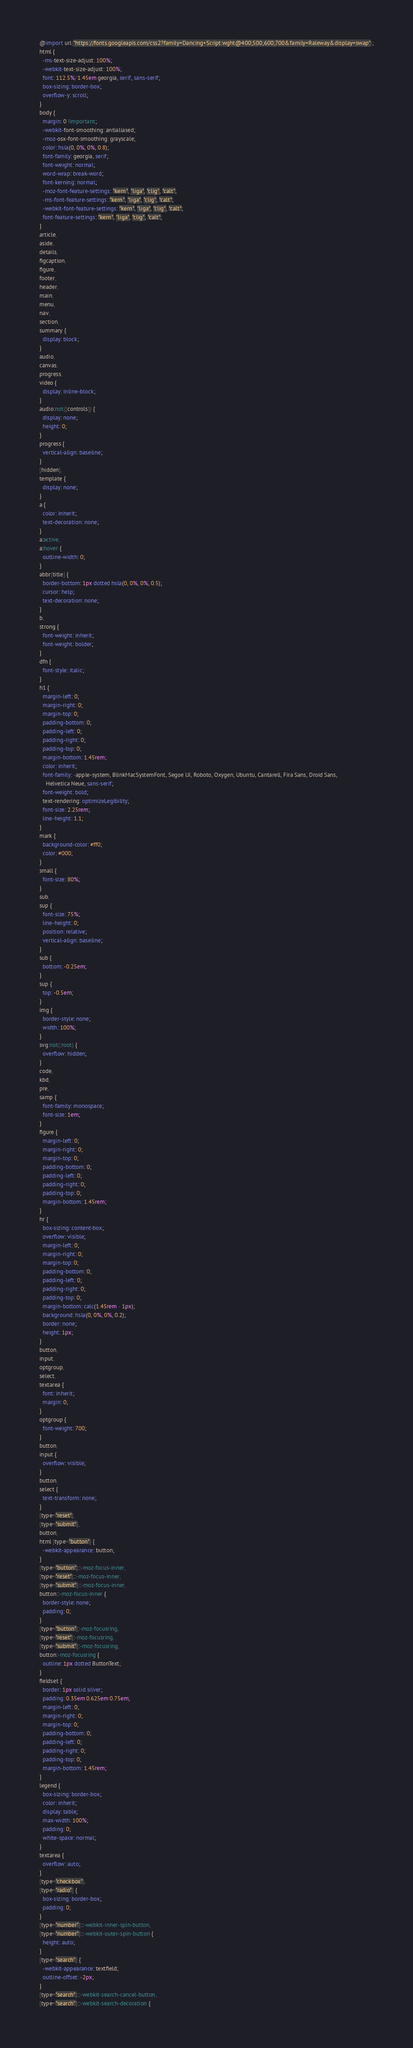<code> <loc_0><loc_0><loc_500><loc_500><_CSS_>@import url("https://fonts.googleapis.com/css2?family=Dancing+Script:wght@400;500;600;700&family=Raleway&display=swap");
html {
  -ms-text-size-adjust: 100%;
  -webkit-text-size-adjust: 100%;
  font: 112.5%/1.45em georgia, serif, sans-serif;
  box-sizing: border-box;
  overflow-y: scroll;
}
body {
  margin: 0 !important;
  -webkit-font-smoothing: antialiased;
  -moz-osx-font-smoothing: grayscale;
  color: hsla(0, 0%, 0%, 0.8);
  font-family: georgia, serif;
  font-weight: normal;
  word-wrap: break-word;
  font-kerning: normal;
  -moz-font-feature-settings: "kern", "liga", "clig", "calt";
  -ms-font-feature-settings: "kern", "liga", "clig", "calt";
  -webkit-font-feature-settings: "kern", "liga", "clig", "calt";
  font-feature-settings: "kern", "liga", "clig", "calt";
}
article,
aside,
details,
figcaption,
figure,
footer,
header,
main,
menu,
nav,
section,
summary {
  display: block;
}
audio,
canvas,
progress,
video {
  display: inline-block;
}
audio:not([controls]) {
  display: none;
  height: 0;
}
progress {
  vertical-align: baseline;
}
[hidden],
template {
  display: none;
}
a {
  color: inherit;
  text-decoration: none;
}
a:active,
a:hover {
  outline-width: 0;
}
abbr[title] {
  border-bottom: 1px dotted hsla(0, 0%, 0%, 0.5);
  cursor: help;
  text-decoration: none;
}
b,
strong {
  font-weight: inherit;
  font-weight: bolder;
}
dfn {
  font-style: italic;
}
h1 {
  margin-left: 0;
  margin-right: 0;
  margin-top: 0;
  padding-bottom: 0;
  padding-left: 0;
  padding-right: 0;
  padding-top: 0;
  margin-bottom: 1.45rem;
  color: inherit;
  font-family: -apple-system, BlinkMacSystemFont, Segoe UI, Roboto, Oxygen, Ubuntu, Cantarell, Fira Sans, Droid Sans,
    Helvetica Neue, sans-serif;
  font-weight: bold;
  text-rendering: optimizeLegibility;
  font-size: 2.25rem;
  line-height: 1.1;
}
mark {
  background-color: #ff0;
  color: #000;
}
small {
  font-size: 80%;
}
sub,
sup {
  font-size: 75%;
  line-height: 0;
  position: relative;
  vertical-align: baseline;
}
sub {
  bottom: -0.25em;
}
sup {
  top: -0.5em;
}
img {
  border-style: none;
  width: 100%;
}
svg:not(:root) {
  overflow: hidden;
}
code,
kbd,
pre,
samp {
  font-family: monospace;
  font-size: 1em;
}
figure {
  margin-left: 0;
  margin-right: 0;
  margin-top: 0;
  padding-bottom: 0;
  padding-left: 0;
  padding-right: 0;
  padding-top: 0;
  margin-bottom: 1.45rem;
}
hr {
  box-sizing: content-box;
  overflow: visible;
  margin-left: 0;
  margin-right: 0;
  margin-top: 0;
  padding-bottom: 0;
  padding-left: 0;
  padding-right: 0;
  padding-top: 0;
  margin-bottom: calc(1.45rem - 1px);
  background: hsla(0, 0%, 0%, 0.2);
  border: none;
  height: 1px;
}
button,
input,
optgroup,
select,
textarea {
  font: inherit;
  margin: 0;
}
optgroup {
  font-weight: 700;
}
button,
input {
  overflow: visible;
}
button,
select {
  text-transform: none;
}
[type="reset"],
[type="submit"],
button,
html [type="button"] {
  -webkit-appearance: button;
}
[type="button"]::-moz-focus-inner,
[type="reset"]::-moz-focus-inner,
[type="submit"]::-moz-focus-inner,
button::-moz-focus-inner {
  border-style: none;
  padding: 0;
}
[type="button"]:-moz-focusring,
[type="reset"]:-moz-focusring,
[type="submit"]:-moz-focusring,
button:-moz-focusring {
  outline: 1px dotted ButtonText;
}
fieldset {
  border: 1px solid silver;
  padding: 0.35em 0.625em 0.75em;
  margin-left: 0;
  margin-right: 0;
  margin-top: 0;
  padding-bottom: 0;
  padding-left: 0;
  padding-right: 0;
  padding-top: 0;
  margin-bottom: 1.45rem;
}
legend {
  box-sizing: border-box;
  color: inherit;
  display: table;
  max-width: 100%;
  padding: 0;
  white-space: normal;
}
textarea {
  overflow: auto;
}
[type="checkbox"],
[type="radio"] {
  box-sizing: border-box;
  padding: 0;
}
[type="number"]::-webkit-inner-spin-button,
[type="number"]::-webkit-outer-spin-button {
  height: auto;
}
[type="search"] {
  -webkit-appearance: textfield;
  outline-offset: -2px;
}
[type="search"]::-webkit-search-cancel-button,
[type="search"]::-webkit-search-decoration {</code> 